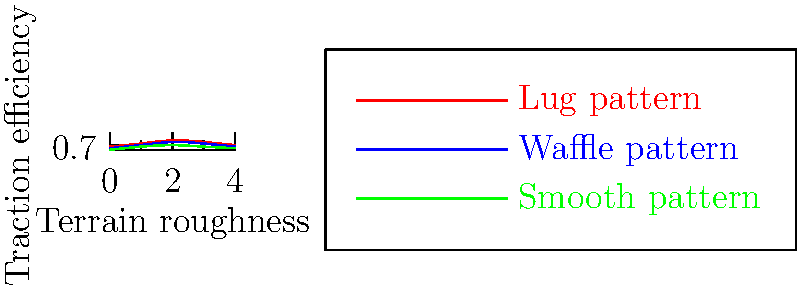Based on the graph showing the traction efficiency of different hiking boot tread patterns across various terrain roughness levels, which tread pattern performs best on moderately rough terrain (roughness level 2), and what is its approximate traction efficiency? To answer this question, we need to follow these steps:

1. Identify the terrain roughness level in question: moderately rough terrain is represented by level 2 on the x-axis.

2. Examine the traction efficiency (y-axis) for each tread pattern at x = 2:
   - Lug pattern (red line): approximately 0.85
   - Waffle pattern (blue line): approximately 0.80
   - Smooth pattern (green line): approximately 0.70

3. Compare the values:
   The lug pattern has the highest traction efficiency at roughness level 2.

4. Determine the approximate traction efficiency:
   The lug pattern's traction efficiency at x = 2 is approximately 0.85 or 85%.

Therefore, the lug pattern performs best on moderately rough terrain with an approximate traction efficiency of 85%.
Answer: Lug pattern, 85% 